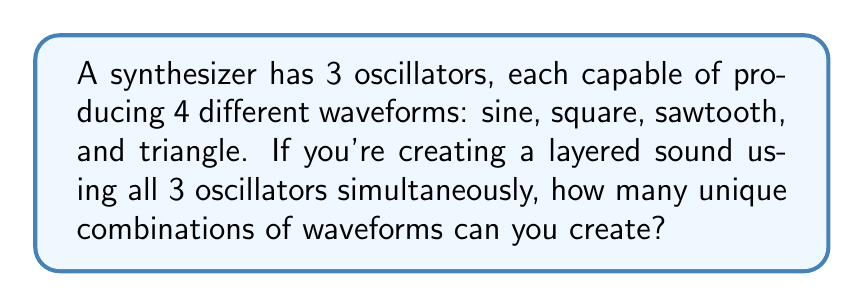Solve this math problem. Let's approach this step-by-step:

1) We have 3 oscillators, and each oscillator can independently choose from 4 waveforms.

2) This scenario can be modeled as a combination with repetition allowed, where the order matters (since each oscillator is distinct).

3) In mathematical terms, this is equivalent to finding the number of ways to make ordered selections from 4 choices, repeated 3 times.

4) The formula for this is:

   $$n^r$$

   where $n$ is the number of choices for each selection, and $r$ is the number of selections being made.

5) In this case:
   $n = 4$ (4 waveform choices)
   $r = 3$ (3 oscillators)

6) Plugging these values into our formula:

   $$4^3 = 4 \times 4 \times 4 = 64$$

Therefore, there are 64 unique combinations of waveforms that can be created using all 3 oscillators simultaneously.
Answer: 64 